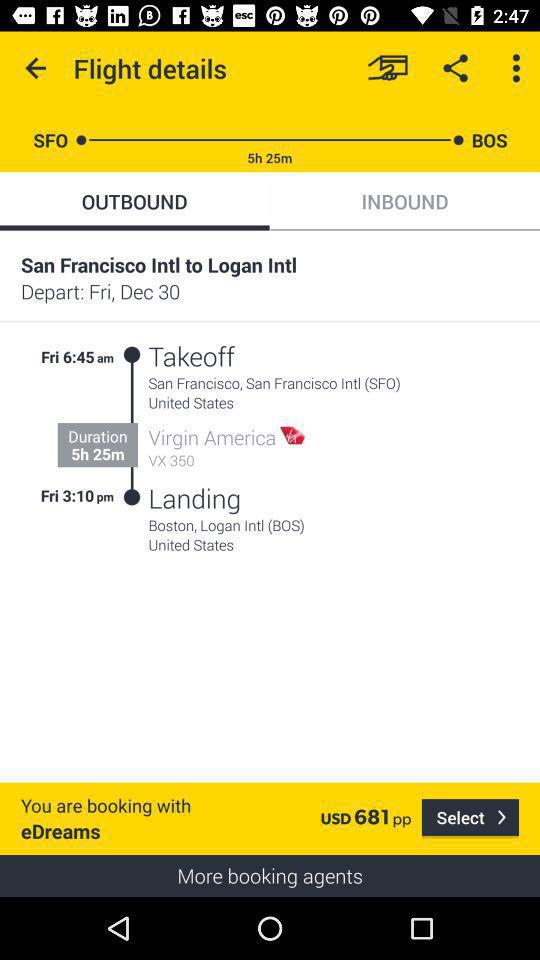What is the duration of the journey? The duration of the journey is 5 hours 25 minutes. 